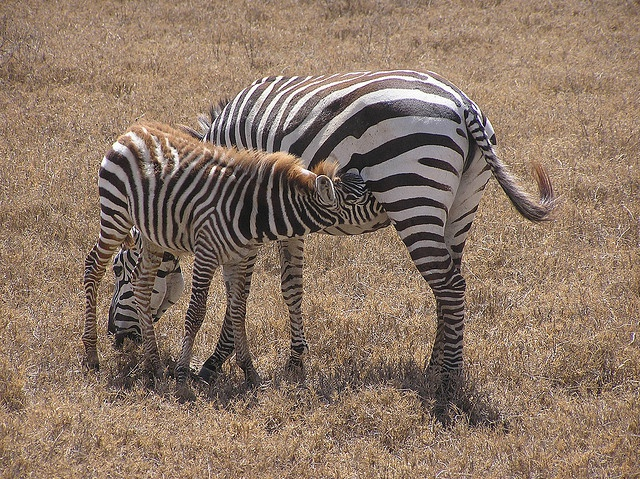Describe the objects in this image and their specific colors. I can see zebra in gray, black, darkgray, and white tones and zebra in gray, black, and darkgray tones in this image. 